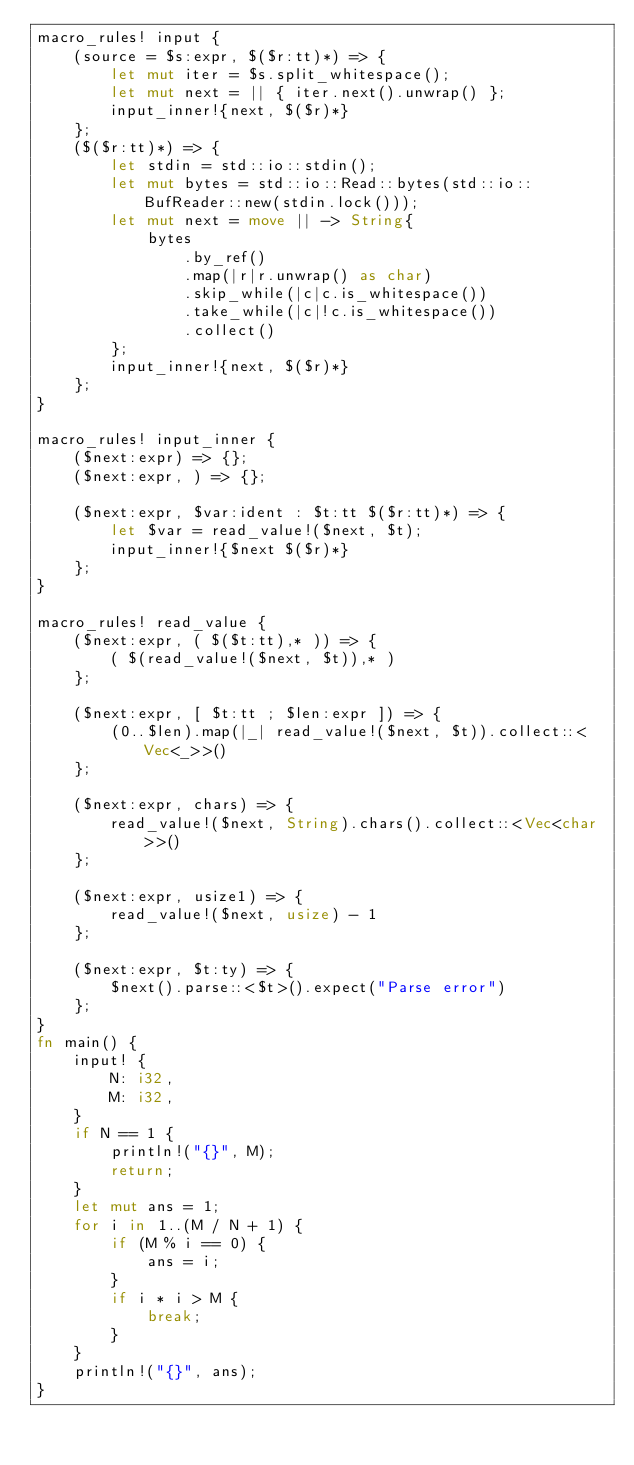Convert code to text. <code><loc_0><loc_0><loc_500><loc_500><_Rust_>macro_rules! input {
    (source = $s:expr, $($r:tt)*) => {
        let mut iter = $s.split_whitespace();
        let mut next = || { iter.next().unwrap() };
        input_inner!{next, $($r)*}
    };
    ($($r:tt)*) => {
        let stdin = std::io::stdin();
        let mut bytes = std::io::Read::bytes(std::io::BufReader::new(stdin.lock()));
        let mut next = move || -> String{
            bytes
                .by_ref()
                .map(|r|r.unwrap() as char)
                .skip_while(|c|c.is_whitespace())
                .take_while(|c|!c.is_whitespace())
                .collect()
        };
        input_inner!{next, $($r)*}
    };
}

macro_rules! input_inner {
    ($next:expr) => {};
    ($next:expr, ) => {};

    ($next:expr, $var:ident : $t:tt $($r:tt)*) => {
        let $var = read_value!($next, $t);
        input_inner!{$next $($r)*}
    };
}

macro_rules! read_value {
    ($next:expr, ( $($t:tt),* )) => {
        ( $(read_value!($next, $t)),* )
    };

    ($next:expr, [ $t:tt ; $len:expr ]) => {
        (0..$len).map(|_| read_value!($next, $t)).collect::<Vec<_>>()
    };

    ($next:expr, chars) => {
        read_value!($next, String).chars().collect::<Vec<char>>()
    };

    ($next:expr, usize1) => {
        read_value!($next, usize) - 1
    };

    ($next:expr, $t:ty) => {
        $next().parse::<$t>().expect("Parse error")
    };
}
fn main() {
    input! {
        N: i32,
        M: i32,
    }
    if N == 1 {
        println!("{}", M);
        return;
    }
    let mut ans = 1;
    for i in 1..(M / N + 1) {
        if (M % i == 0) {
            ans = i;
        }
        if i * i > M {
            break;
        }
    }
    println!("{}", ans);
}
</code> 